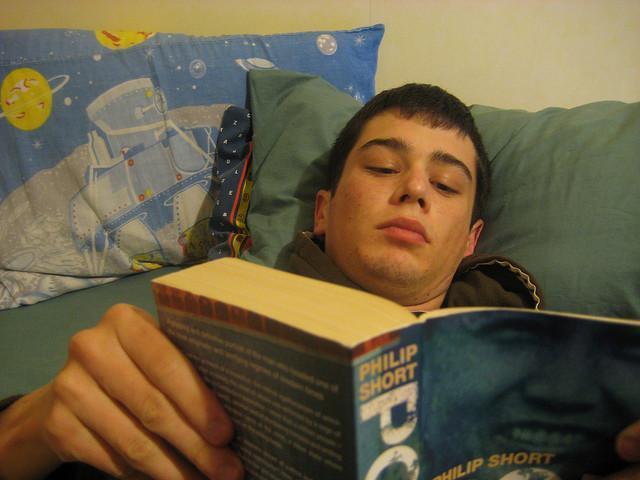How many zebras are there?
Give a very brief answer. 0. 